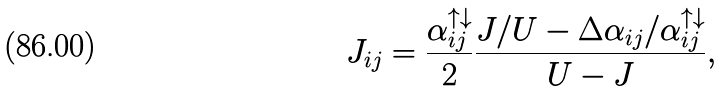<formula> <loc_0><loc_0><loc_500><loc_500>J _ { i j } = \frac { \alpha _ { i j } ^ { \uparrow \downarrow } } { 2 } \frac { J / U - \Delta \alpha _ { i j } / \alpha _ { i j } ^ { \uparrow \downarrow } } { U - J } ,</formula> 